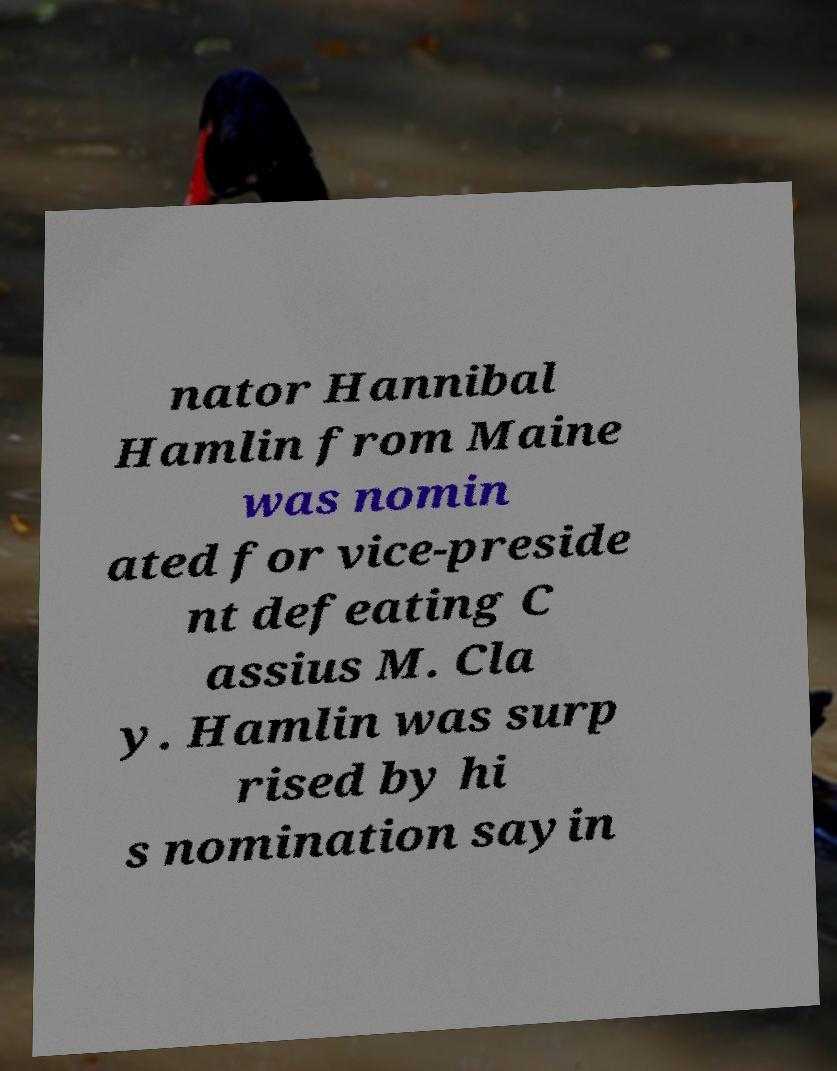There's text embedded in this image that I need extracted. Can you transcribe it verbatim? nator Hannibal Hamlin from Maine was nomin ated for vice-preside nt defeating C assius M. Cla y. Hamlin was surp rised by hi s nomination sayin 